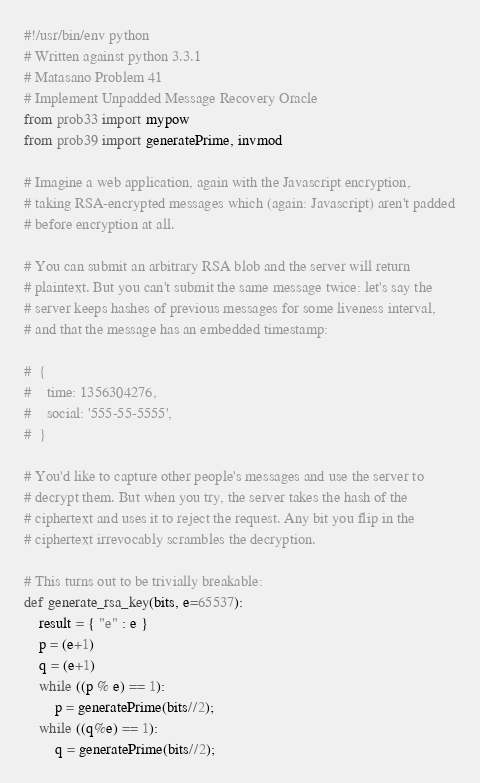Convert code to text. <code><loc_0><loc_0><loc_500><loc_500><_Python_>#!/usr/bin/env python
# Written against python 3.3.1
# Matasano Problem 41
# Implement Unpadded Message Recovery Oracle
from prob33 import mypow
from prob39 import generatePrime, invmod

# Imagine a web application, again with the Javascript encryption,
# taking RSA-encrypted messages which (again: Javascript) aren't padded
# before encryption at all.

# You can submit an arbitrary RSA blob and the server will return
# plaintext. But you can't submit the same message twice: let's say the
# server keeps hashes of previous messages for some liveness interval,
# and that the message has an embedded timestamp:

#  {
#    time: 1356304276,
#    social: '555-55-5555',
#  }

# You'd like to capture other people's messages and use the server to
# decrypt them. But when you try, the server takes the hash of the
# ciphertext and uses it to reject the request. Any bit you flip in the
# ciphertext irrevocably scrambles the decryption.

# This turns out to be trivially breakable:
def generate_rsa_key(bits, e=65537):
    result = { "e" : e }
    p = (e+1)
    q = (e+1)
    while ((p % e) == 1):
        p = generatePrime(bits//2);
    while ((q%e) == 1):
        q = generatePrime(bits//2);</code> 